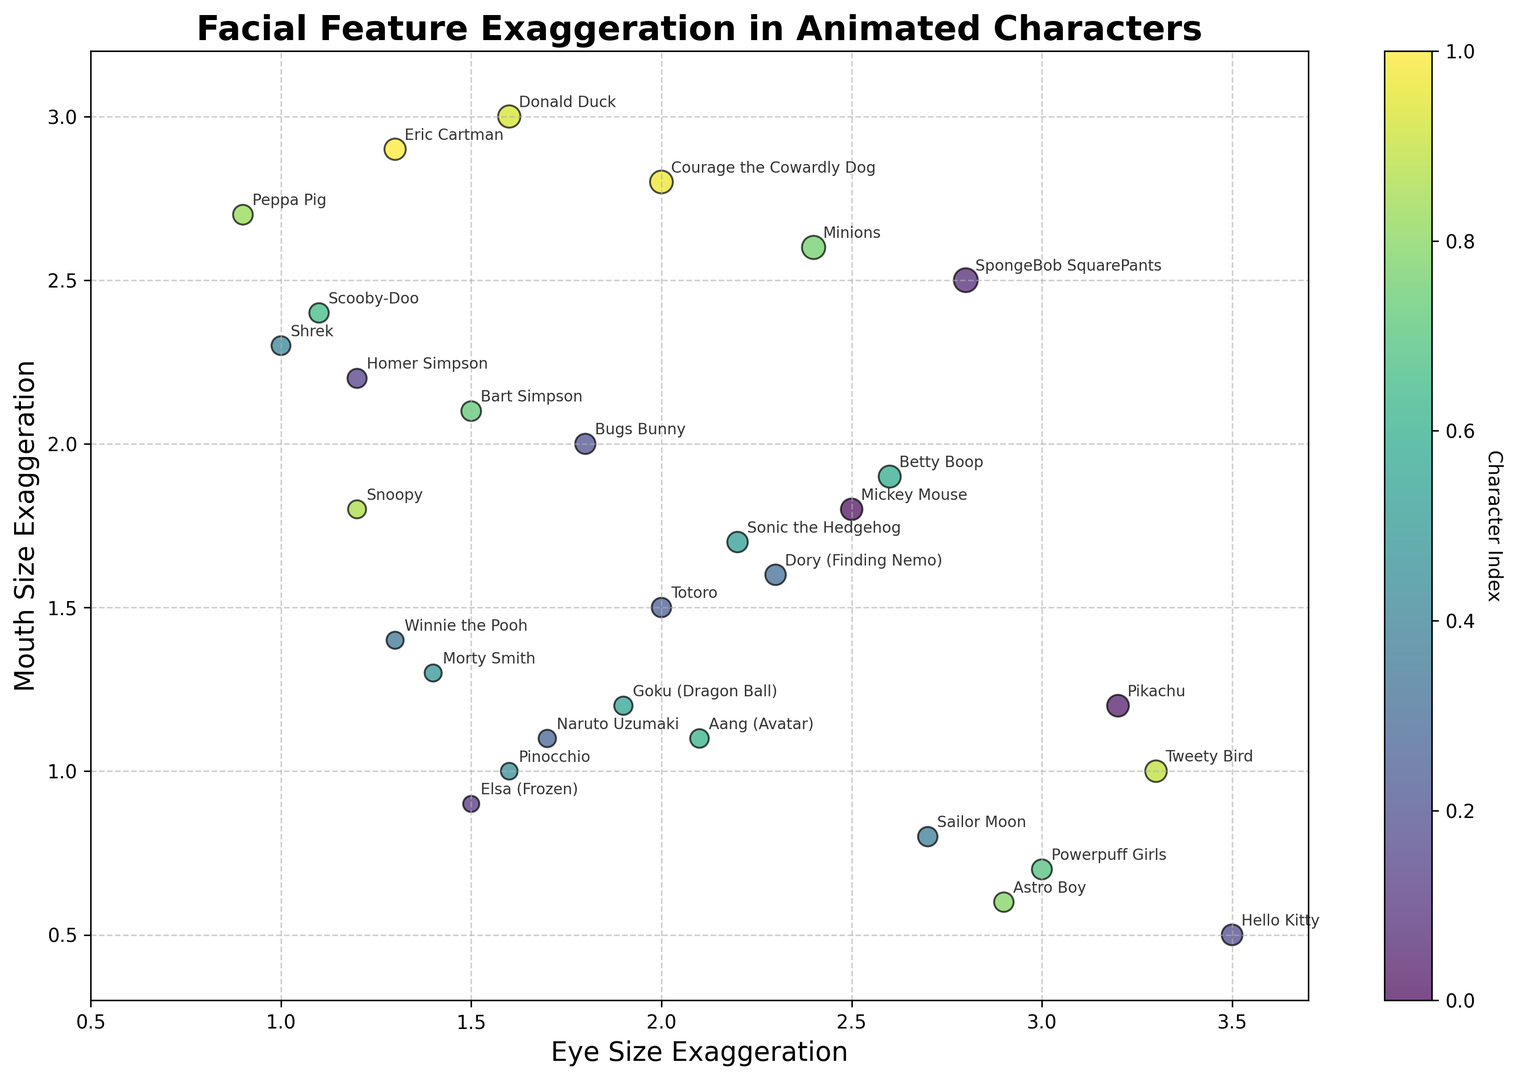Which character has the highest mouth size exaggeration? To answer this, we look at the mouth size exaggeration axis and find the character with the highest value. Donald Duck has the highest value at 3.0.
Answer: Donald Duck Which character has both eye and mouth size exaggerations above 3.0? We identify characters where both the eye size exaggeration and mouth size exaggeration are greater than 3.0. Courage the Cowardly Dog has eye size exaggeration 2.0 and mouth size exaggeration 2.8, so no character meets this criteria.
Answer: None Which characters are closest to each other in terms of facial feature exaggerations? We find characters whose coordinates (eye size exaggeration, mouth size exaggeration) are nearly the same. Astro Boy (2.9, 0.6) and Powerpuff Girls (3.0, 0.7) are very close.
Answer: Astro Boy, Powerpuff Girls Who has the smallest eye size exaggeration? Look at the eye size axis and find the smallest value. Peppa Pig has the smallest eye size exaggeration at 0.9.
Answer: Peppa Pig Who has the smallest mouth size exaggeration? Look at the mouth size axis and find the smallest value. Hello Kitty has the smallest mouth size exaggeration at 0.5.
Answer: Hello Kitty Which character lies at approximately the midpoint of the entire scatter plot? Estimate the midpoints of the axes by averaging the range of values and see which character lies closest to (2.1, 1.75). Aang has values (2.1, 1.1), which is close to the midpoint.
Answer: Aang Do any characters have an equal level of eye and mouth size exaggerations? Look for characters where the eye size exaggeration is equal to the mouth size exaggeration. No characters have exactly equal levels.
Answer: None What is the approximate range of eye size exaggerations in this plot? Look at the x-axis and identify the smallest and largest values. The range is 0.9 (Peppa Pig) to 3.5 (Hello Kitty).
Answer: 0.9 to 3.5 Which character has an eye size exaggeration significantly larger than their mouth size exaggeration? Compare the eye and mouth size exaggerations and find a significant difference. Pikachu has an eye size exaggeration of 3.2 and mouth size exaggeration of 1.2, which is a large difference.
Answer: Pikachu Is there a character that stands out visually due to the size and color of its scatter point? Notice the character with a notably larger or differently colored point in the scatter plot. Minions has a large dot size and distinct color due to high total exaggeration levels (eye size 2.4, mouth size 2.6).
Answer: Minions 